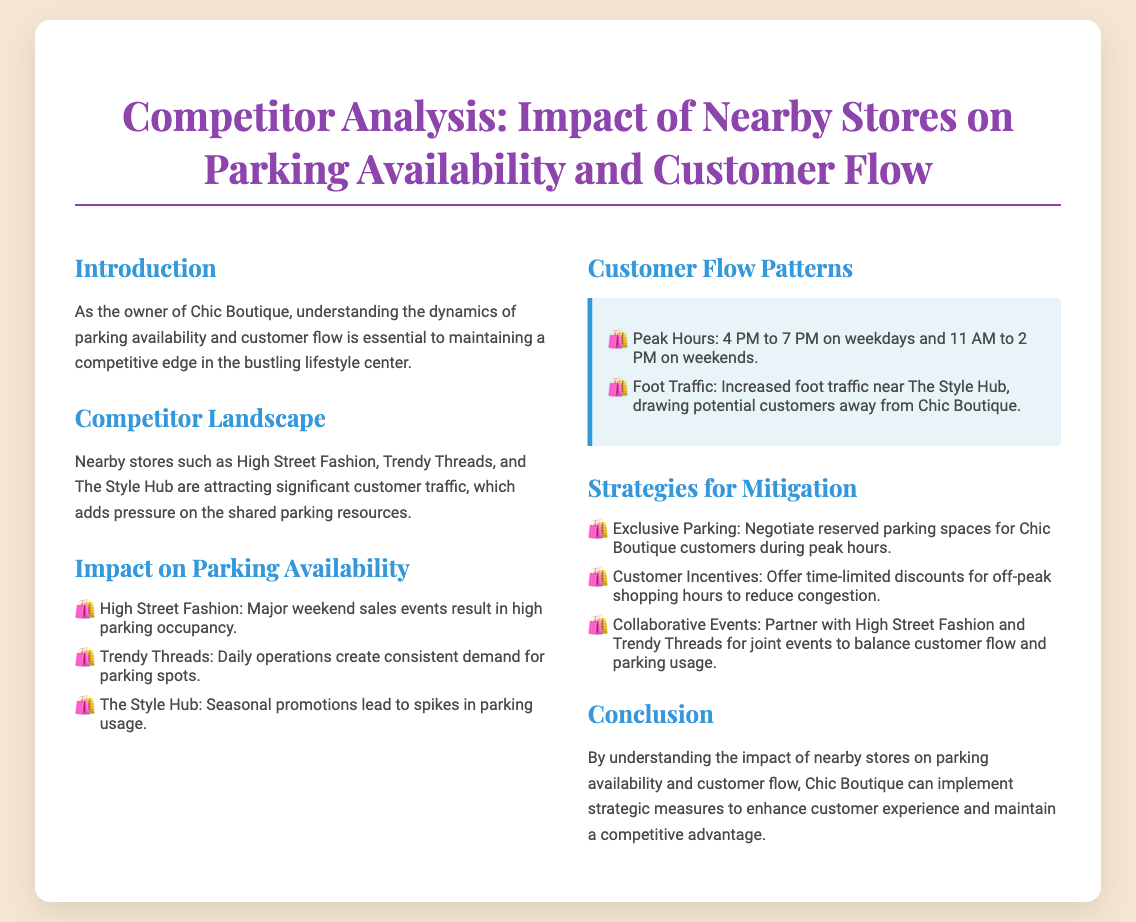What is the primary focus of the presentation? The primary focus is on how nearby stores impact parking availability and customer flow for Chic Boutique.
Answer: Parking availability and customer flow Which stores are identified as competitors? The document names three competitors directly influencing parking and customer flow.
Answer: High Street Fashion, Trendy Threads, The Style Hub What are the peak hours for parking mentioned? The slide specifies the peak hours which affect customer flow and parking availability.
Answer: 4 PM to 7 PM on weekdays and 11 AM to 2 PM on weekends What strategy involves negotiating reserved spaces? The presentation suggests a specific strategy to improve parking for Chic Boutique customers during busy times.
Answer: Exclusive Parking Which store sees increased foot traffic affecting Chic Boutique? The document highlights a specific competitor that draws more customers, impacting the boutique's flow.
Answer: The Style Hub 